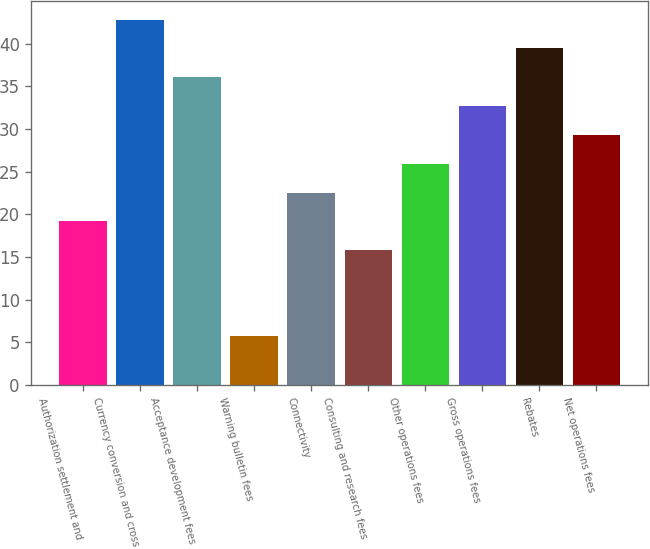Convert chart. <chart><loc_0><loc_0><loc_500><loc_500><bar_chart><fcel>Authorization settlement and<fcel>Currency conversion and cross<fcel>Acceptance development fees<fcel>Warning bulletin fees<fcel>Connectivity<fcel>Consulting and research fees<fcel>Other operations fees<fcel>Gross operations fees<fcel>Rebates<fcel>Net operations fees<nl><fcel>19.18<fcel>42.84<fcel>36.08<fcel>5.7<fcel>22.56<fcel>15.8<fcel>25.94<fcel>32.7<fcel>39.46<fcel>29.32<nl></chart> 